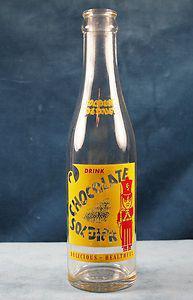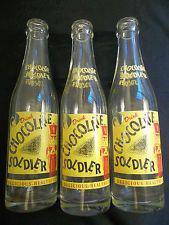The first image is the image on the left, the second image is the image on the right. Assess this claim about the two images: "Each image shows a single glass bottle, at least one of the pictured bottles is empty, and at least one bottle has a red 'toy soldier' depicted on the front.". Correct or not? Answer yes or no. No. The first image is the image on the left, the second image is the image on the right. Analyze the images presented: Is the assertion "The right image contains exactly three bottles." valid? Answer yes or no. Yes. 